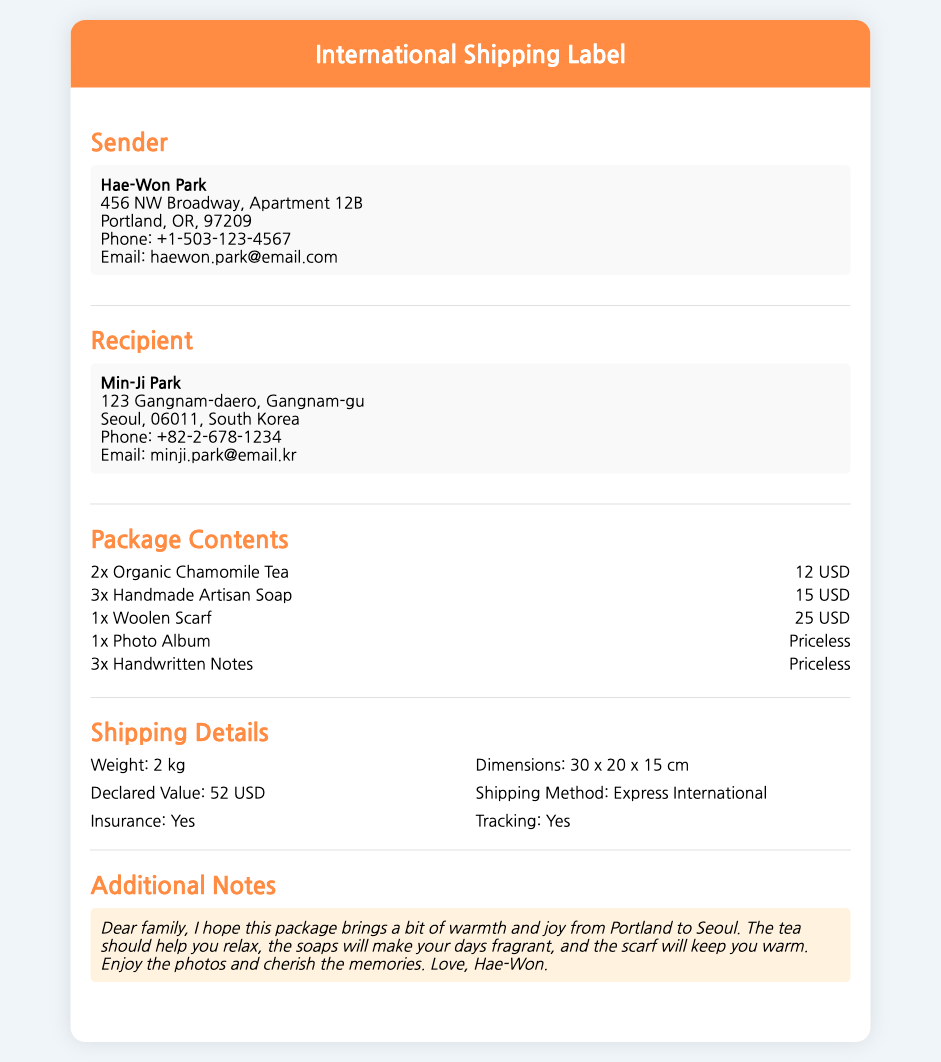What is the sender's name? The sender's name is located in the "Sender" section of the document.
Answer: Hae-Won Park What is the recipient's email? The recipient's email can be found in the "Recipient" section.
Answer: minji.park@email.kr How many pieces of chamomile tea are in the package? The number of chamomile tea pieces is specified in the "Package Contents" section.
Answer: 2x What is the declared value of the package? The declared value is listed in the "Shipping Details" section.
Answer: 52 USD What is the shipping method used? The shipping method is indicated in the "Shipping Details" section.
Answer: Express International What additional items are included in the package besides gifts? The additional items are mentioned in the "Package Contents" section as handwritten notes.
Answer: 3x Handwritten Notes What is the weight of the package? The weight is provided in the "Shipping Details" section.
Answer: 2 kg What is the purpose of the additional notes? The additional notes aim to convey warmth and joy from the sender.
Answer: To convey warmth and joy What kind of scarf is included? The type of scarf is specified in the "Package Contents" section.
Answer: Woolen Scarf 